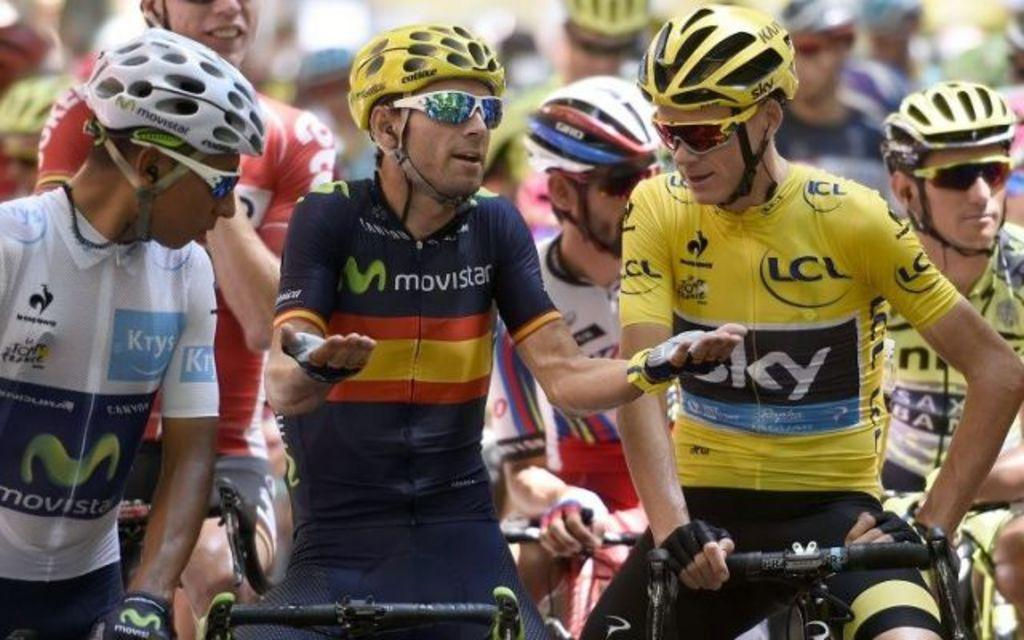Who or what can be seen in the image? There are people in the image. What are the people doing in the image? The people are riding bicycles. What safety precautions are the people taking while riding bicycles? The people are wearing helmets. Are there any additional accessories being worn by the people in the image? Some of the people are wearing sunglasses. What type of card can be seen being played by the people in the image? There is no card or card game present in the image; the people are riding bicycles. 